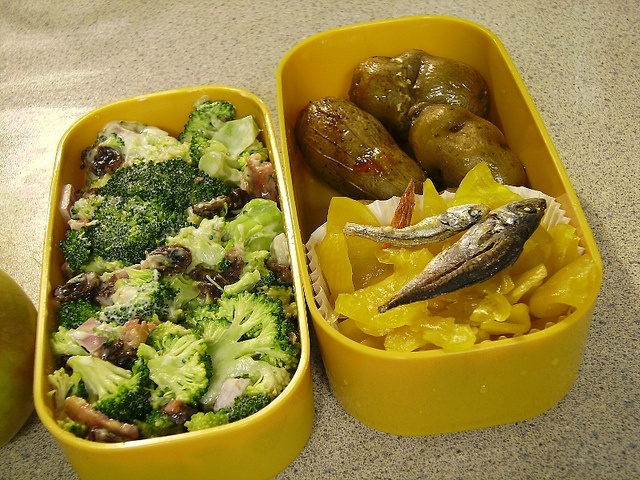Describe the objects in this image and their specific colors. I can see dining table in olive and tan tones, bowl in tan, olive, and gold tones, bowl in tan, olive, and black tones, broccoli in tan, black, darkgreen, and olive tones, and broccoli in tan, khaki, and olive tones in this image. 